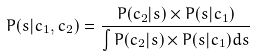Convert formula to latex. <formula><loc_0><loc_0><loc_500><loc_500>P ( s | c _ { 1 } , c _ { 2 } ) = \frac { P ( c _ { 2 } | s ) \times P ( s | c _ { 1 } ) } { \int P ( c _ { 2 } | s ) \times P ( s | c _ { 1 } ) d s }</formula> 